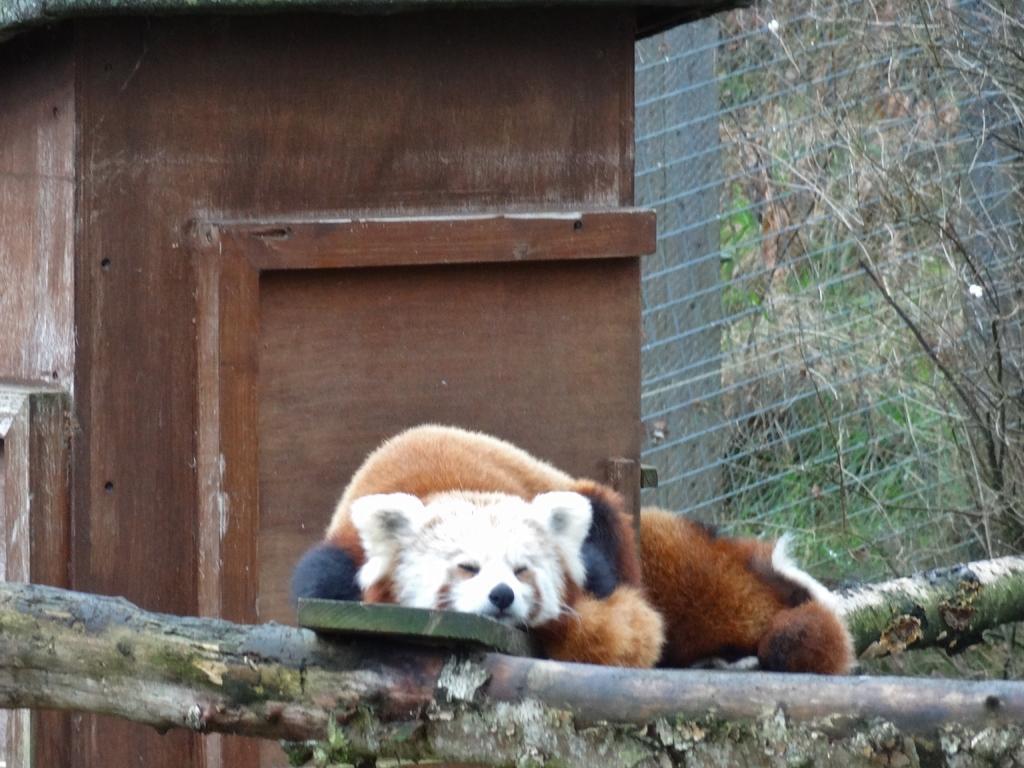Describe this image in one or two sentences. In this image in the center there is an animal sleeping. In the background there is a fence, there are trees and there's grass on the ground. On the left side there is a wooden object. In the front there is a branch of a tree. 